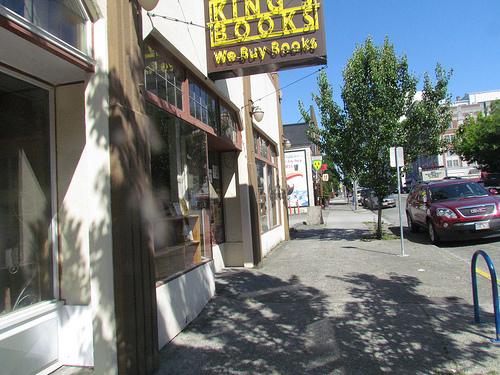<image>
Is there a shadow under the sky? Yes. The shadow is positioned underneath the sky, with the sky above it in the vertical space. 